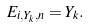<formula> <loc_0><loc_0><loc_500><loc_500>E _ { i , Y _ { k } , n } = Y _ { k } .</formula> 